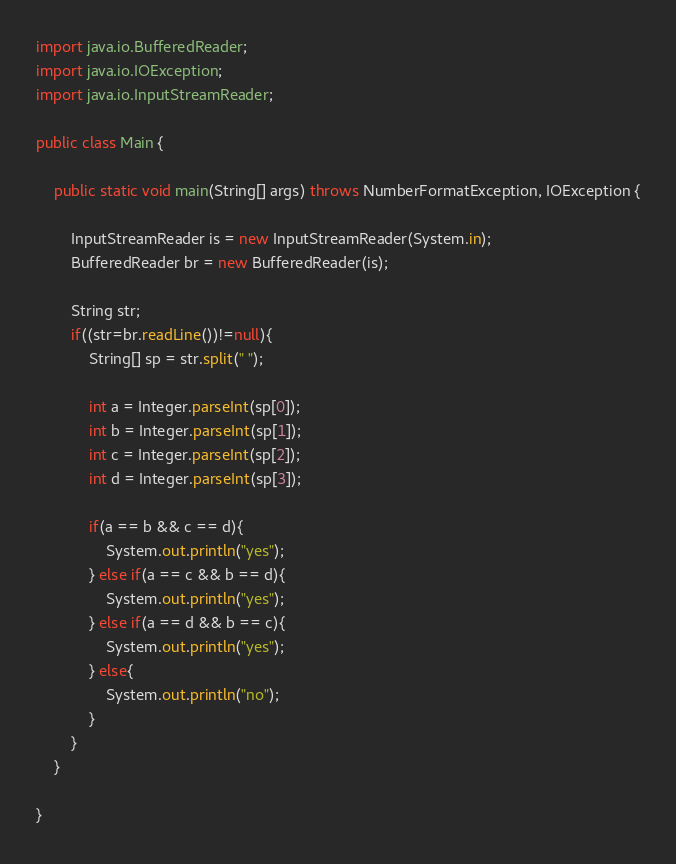<code> <loc_0><loc_0><loc_500><loc_500><_Java_>import java.io.BufferedReader;
import java.io.IOException;
import java.io.InputStreamReader;

public class Main {

	public static void main(String[] args) throws NumberFormatException, IOException {

		InputStreamReader is = new InputStreamReader(System.in);
		BufferedReader br = new BufferedReader(is);

		String str;
		if((str=br.readLine())!=null){
			String[] sp = str.split(" ");

			int a = Integer.parseInt(sp[0]);
			int b = Integer.parseInt(sp[1]);
			int c = Integer.parseInt(sp[2]);
			int d = Integer.parseInt(sp[3]);

			if(a == b && c == d){
				System.out.println("yes");
			} else if(a == c && b == d){
				System.out.println("yes");
			} else if(a == d && b == c){
				System.out.println("yes");
			} else{
				System.out.println("no");
			}
		}
	}

}</code> 